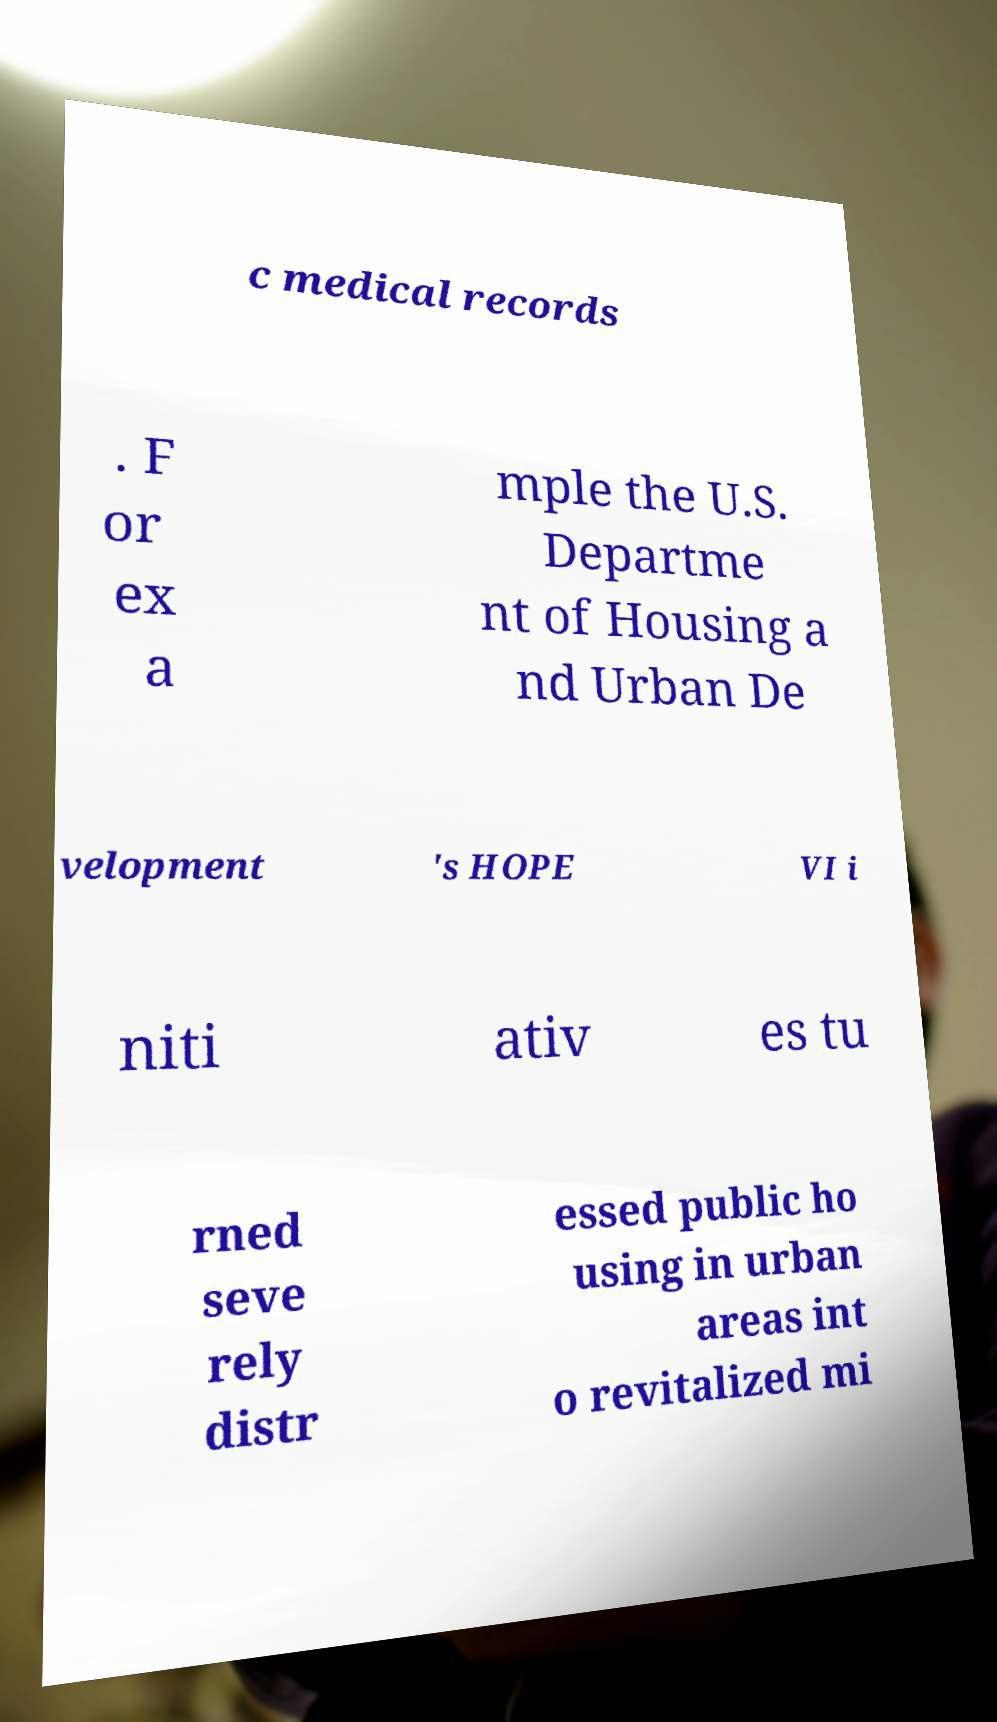For documentation purposes, I need the text within this image transcribed. Could you provide that? c medical records . F or ex a mple the U.S. Departme nt of Housing a nd Urban De velopment 's HOPE VI i niti ativ es tu rned seve rely distr essed public ho using in urban areas int o revitalized mi 